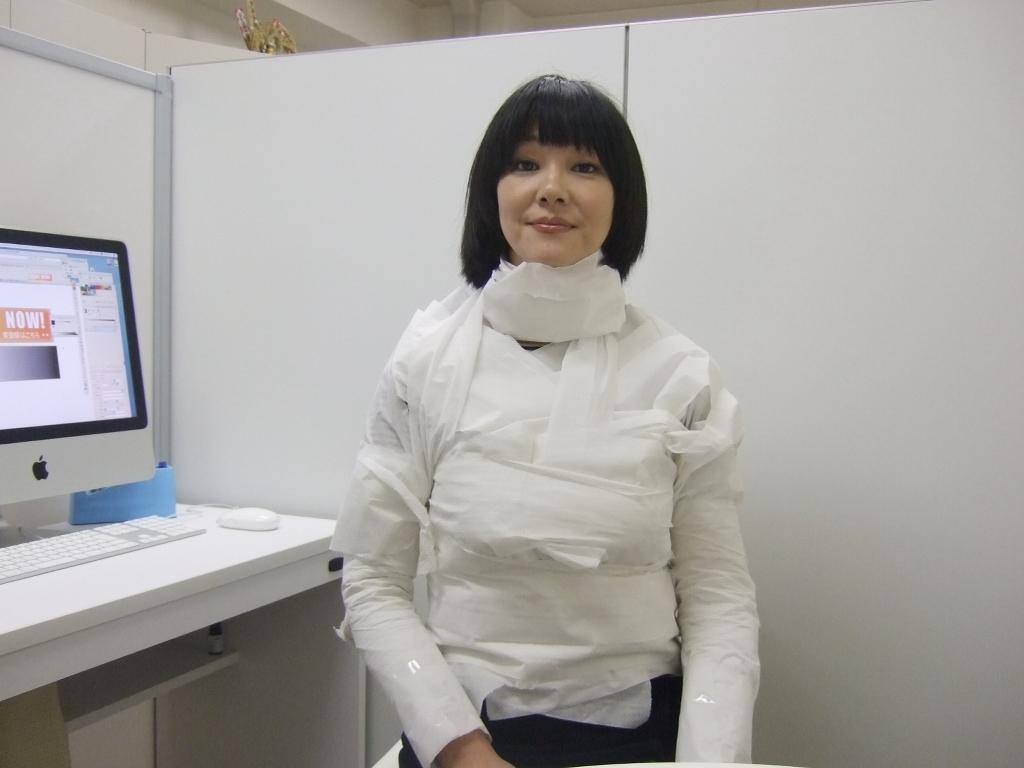Who is the main subject in the foreground of the image? There is a woman in the foreground of the image. What is a notable feature of the woman's appearance? The woman has black hair. What can be seen on the left side of the image? There is a system on the left side of the image. What type of vest is the woman wearing in the image? There is no vest visible in the image; the woman is not wearing any clothing item that resembles a vest. 